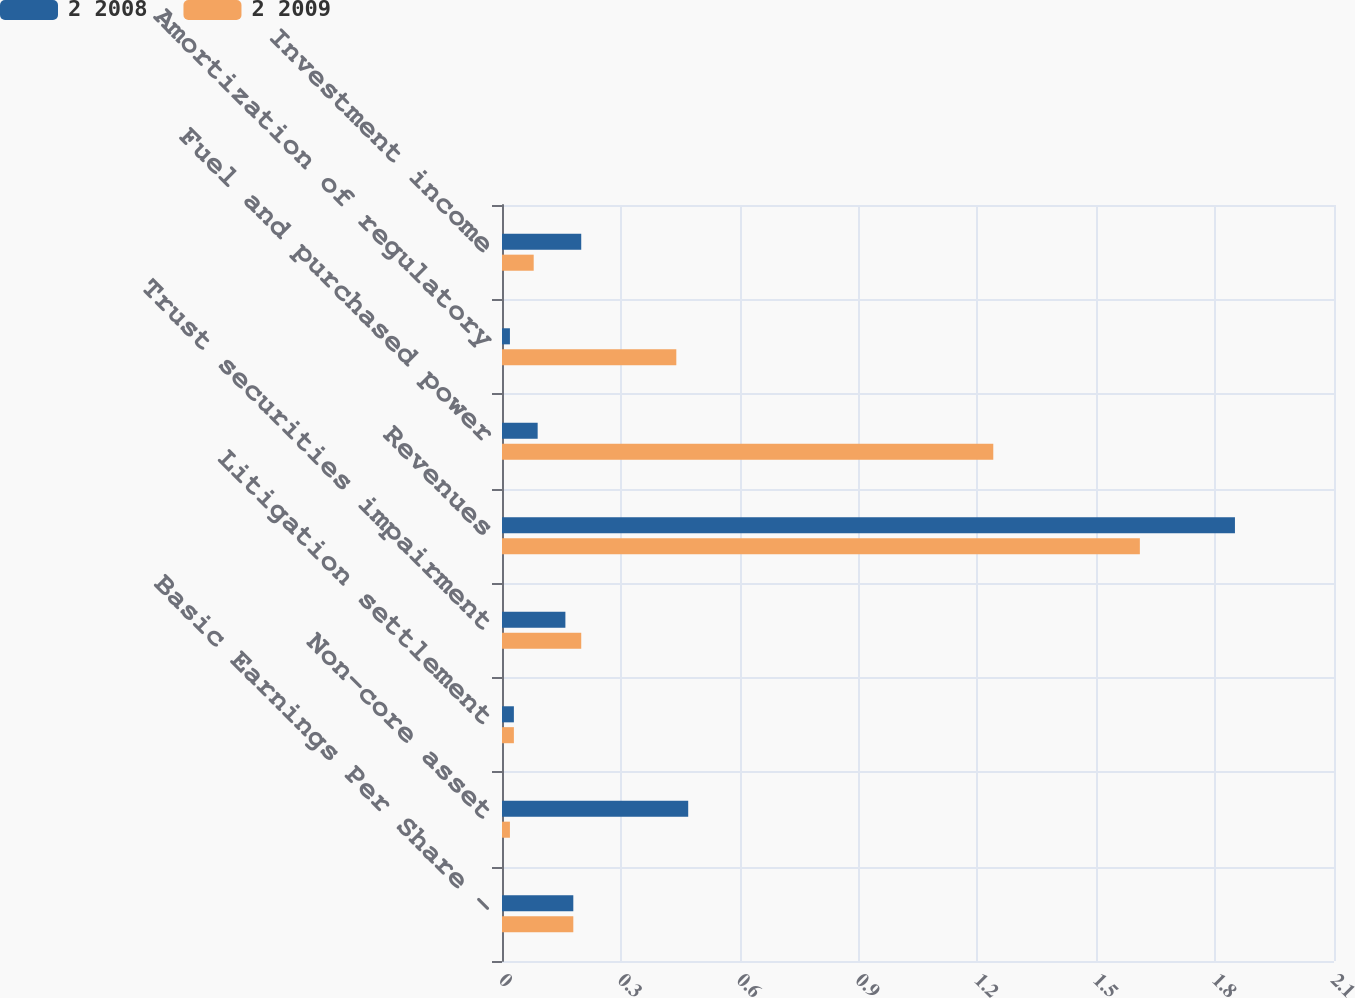Convert chart to OTSL. <chart><loc_0><loc_0><loc_500><loc_500><stacked_bar_chart><ecel><fcel>Basic Earnings Per Share -<fcel>Non-core asset<fcel>Litigation settlement<fcel>Trust securities impairment<fcel>Revenues<fcel>Fuel and purchased power<fcel>Amortization of regulatory<fcel>Investment income<nl><fcel>2 2008<fcel>0.18<fcel>0.47<fcel>0.03<fcel>0.16<fcel>1.85<fcel>0.09<fcel>0.02<fcel>0.2<nl><fcel>2 2009<fcel>0.18<fcel>0.02<fcel>0.03<fcel>0.2<fcel>1.61<fcel>1.24<fcel>0.44<fcel>0.08<nl></chart> 